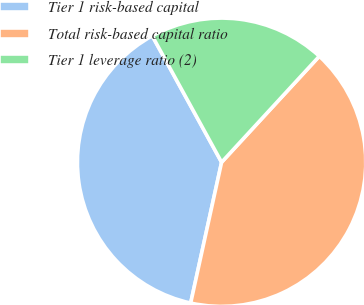<chart> <loc_0><loc_0><loc_500><loc_500><pie_chart><fcel>Tier 1 risk-based capital<fcel>Total risk-based capital ratio<fcel>Tier 1 leverage ratio (2)<nl><fcel>38.57%<fcel>41.59%<fcel>19.84%<nl></chart> 